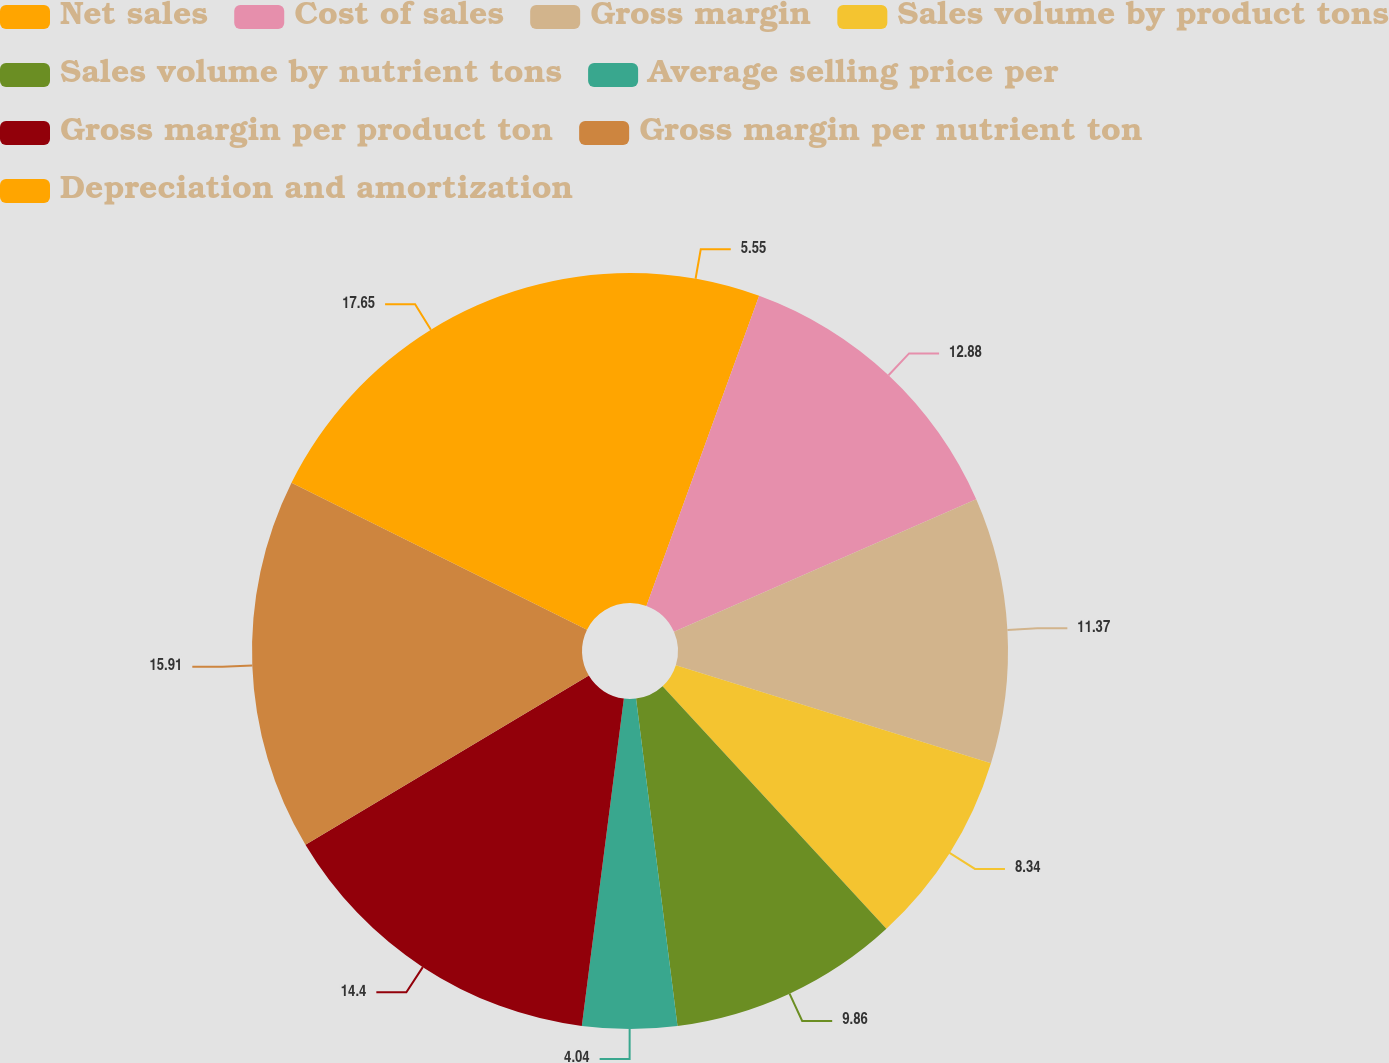Convert chart. <chart><loc_0><loc_0><loc_500><loc_500><pie_chart><fcel>Net sales<fcel>Cost of sales<fcel>Gross margin<fcel>Sales volume by product tons<fcel>Sales volume by nutrient tons<fcel>Average selling price per<fcel>Gross margin per product ton<fcel>Gross margin per nutrient ton<fcel>Depreciation and amortization<nl><fcel>5.55%<fcel>12.88%<fcel>11.37%<fcel>8.34%<fcel>9.86%<fcel>4.04%<fcel>14.4%<fcel>15.91%<fcel>17.66%<nl></chart> 